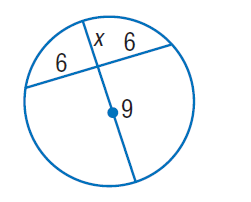Question: Find x. Round to the nearest tenth if necessary. Assume that segments that appear to be tangent are tangent.
Choices:
A. 4
B. 6
C. 9
D. 12
Answer with the letter. Answer: A 